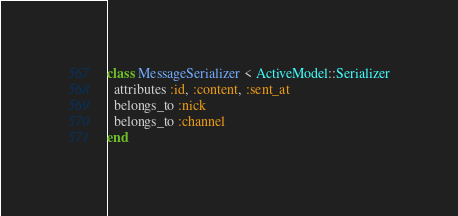Convert code to text. <code><loc_0><loc_0><loc_500><loc_500><_Ruby_>class MessageSerializer < ActiveModel::Serializer
  attributes :id, :content, :sent_at
  belongs_to :nick
  belongs_to :channel
end
</code> 